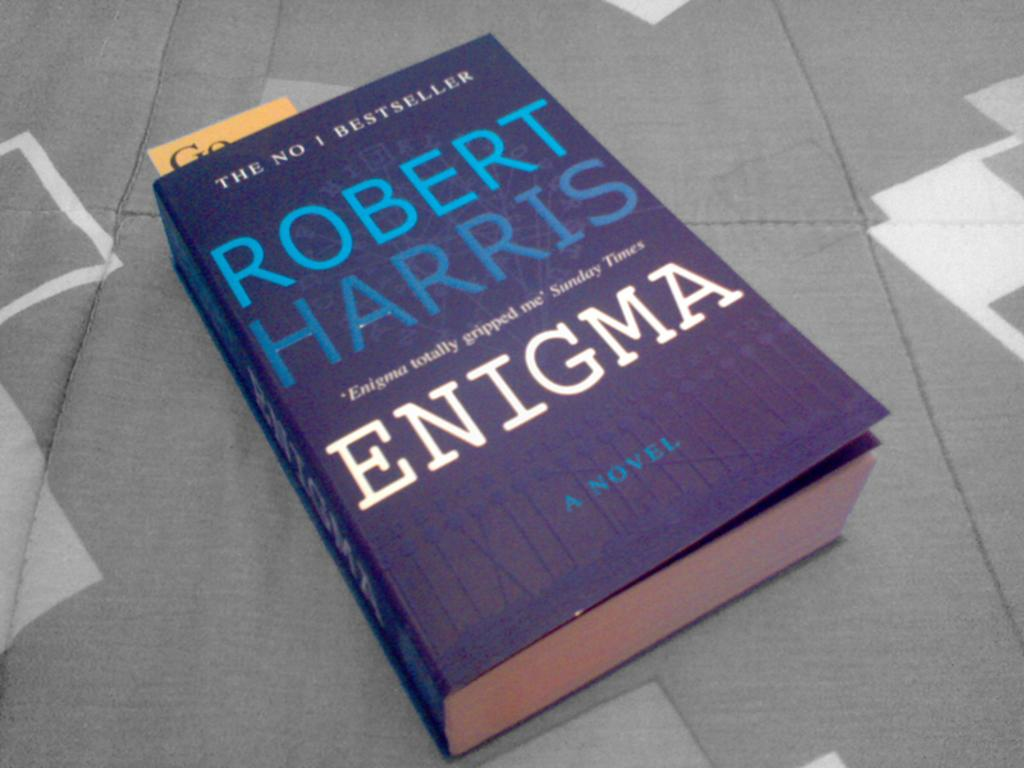<image>
Share a concise interpretation of the image provided. A blue book titled Enigma by Robert Harris. 